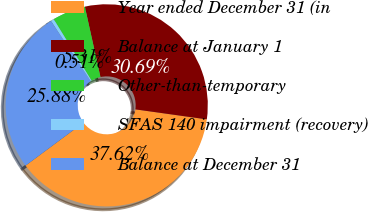<chart> <loc_0><loc_0><loc_500><loc_500><pie_chart><fcel>Year ended December 31 (in<fcel>Balance at January 1<fcel>Other-than-temporary<fcel>SFAS 140 impairment (recovery)<fcel>Balance at December 31<nl><fcel>37.62%<fcel>30.69%<fcel>5.31%<fcel>0.51%<fcel>25.88%<nl></chart> 